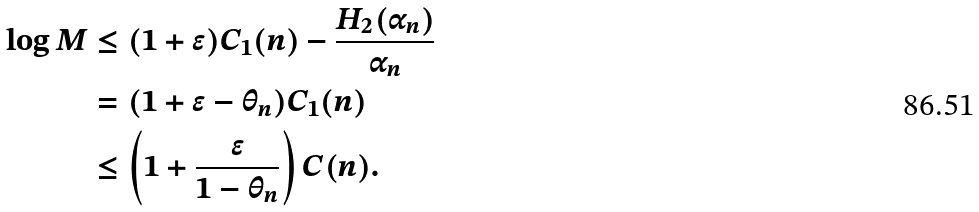<formula> <loc_0><loc_0><loc_500><loc_500>\log M & \leq ( 1 + \epsilon ) C _ { 1 } ( n ) - \frac { H _ { 2 } ( \alpha _ { n } ) } { \alpha _ { n } } \\ & = ( 1 + \epsilon - \theta _ { n } ) C _ { 1 } ( n ) \\ & \leq \left ( 1 + \frac { \epsilon } { 1 - \theta _ { n } } \right ) C ( n ) .</formula> 